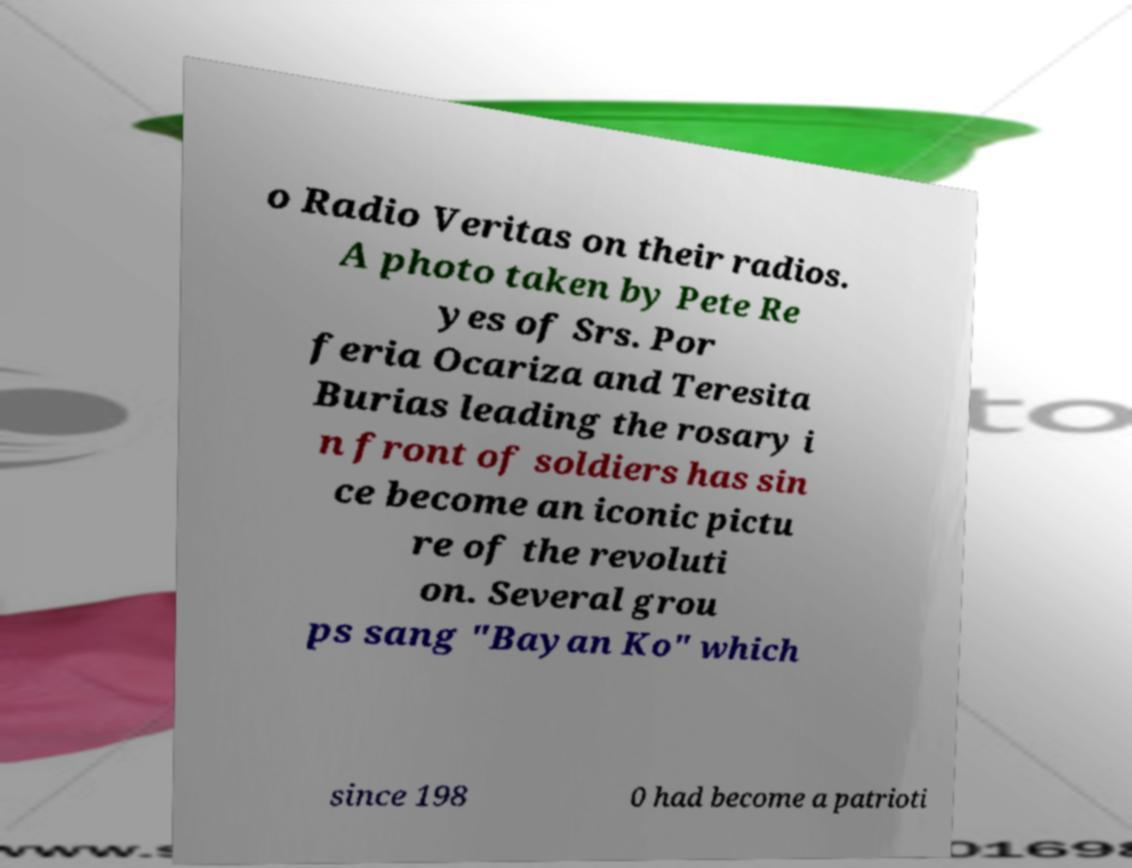Can you read and provide the text displayed in the image?This photo seems to have some interesting text. Can you extract and type it out for me? o Radio Veritas on their radios. A photo taken by Pete Re yes of Srs. Por feria Ocariza and Teresita Burias leading the rosary i n front of soldiers has sin ce become an iconic pictu re of the revoluti on. Several grou ps sang "Bayan Ko" which since 198 0 had become a patrioti 